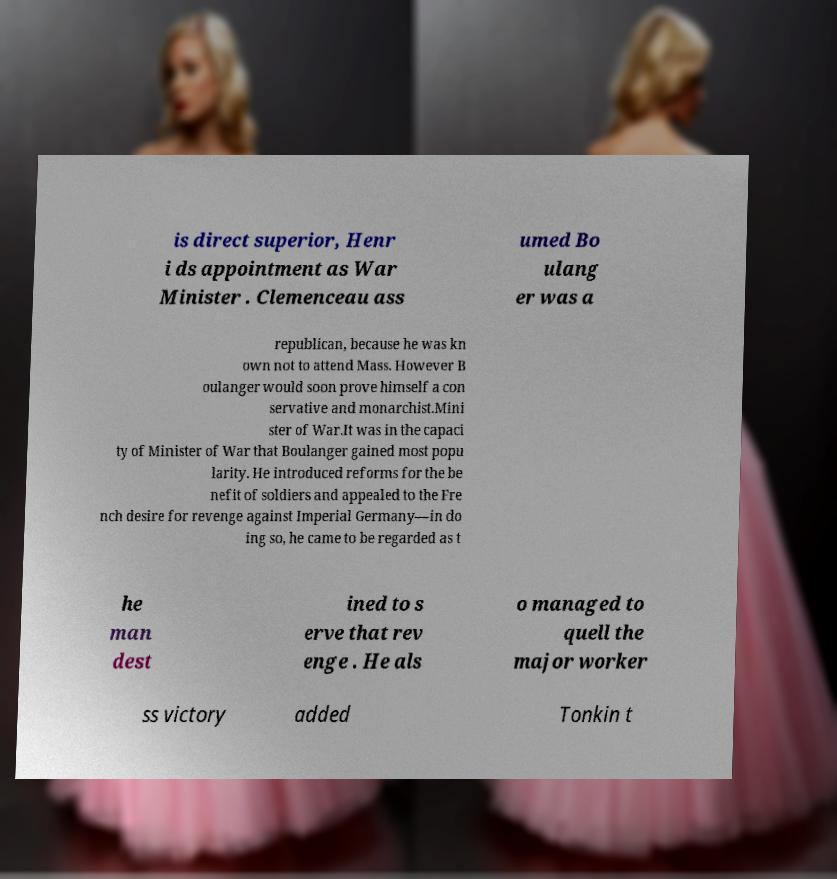Please read and relay the text visible in this image. What does it say? is direct superior, Henr i ds appointment as War Minister . Clemenceau ass umed Bo ulang er was a republican, because he was kn own not to attend Mass. However B oulanger would soon prove himself a con servative and monarchist.Mini ster of War.It was in the capaci ty of Minister of War that Boulanger gained most popu larity. He introduced reforms for the be nefit of soldiers and appealed to the Fre nch desire for revenge against Imperial Germany—in do ing so, he came to be regarded as t he man dest ined to s erve that rev enge . He als o managed to quell the major worker ss victory added Tonkin t 